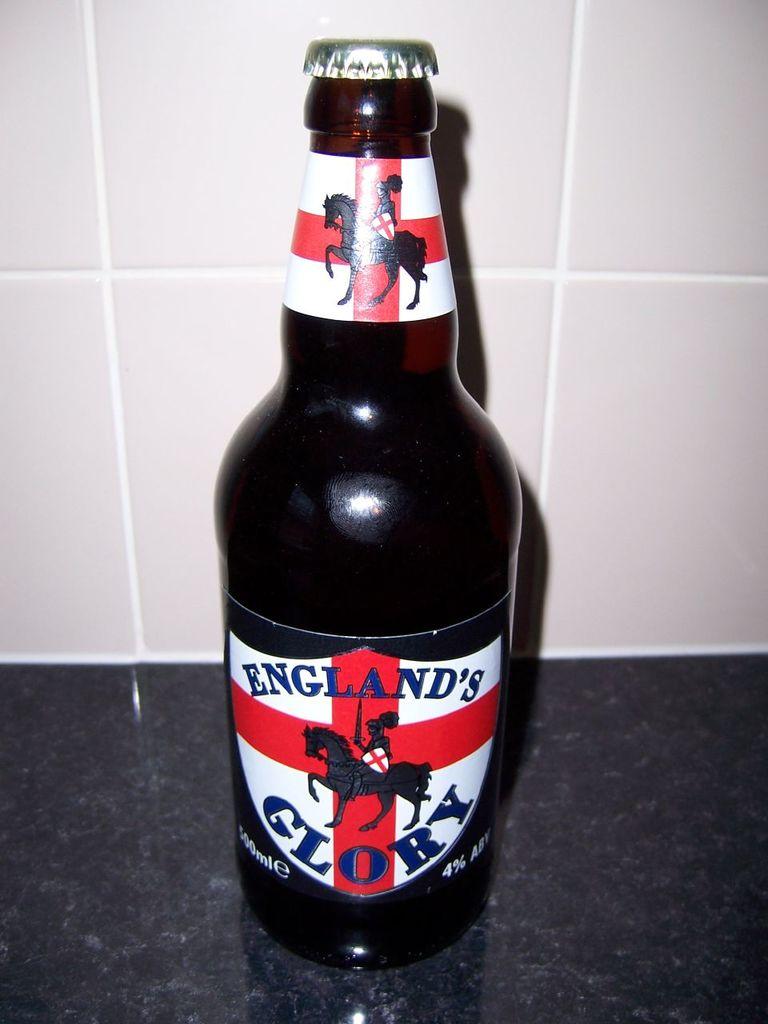What is the name of the beer?
Offer a terse response. England's glory. 